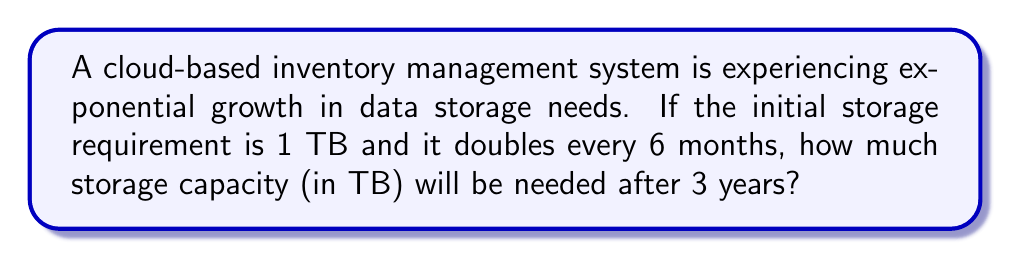Solve this math problem. Let's approach this step-by-step:

1) First, we need to identify the key components of the exponential sequence:
   - Initial value: $a = 1$ TB
   - Growth factor: $r = 2$ (doubles every period)
   - Time periods: $n = 6$ (3 years = 36 months, which is 6 six-month periods)

2) The general formula for an exponential sequence is:
   $$ a_n = a \cdot r^n $$
   Where $a_n$ is the value after $n$ periods, $a$ is the initial value, $r$ is the growth factor, and $n$ is the number of periods.

3) Plugging in our values:
   $$ a_6 = 1 \cdot 2^6 $$

4) Calculate $2^6$:
   $$ 2^6 = 2 \times 2 \times 2 \times 2 \times 2 \times 2 = 64 $$

5) Therefore, the final storage capacity needed after 3 years will be:
   $$ a_6 = 1 \cdot 64 = 64 \text{ TB} $$

This exponential growth demonstrates the rapid scalability required for cloud resources in a fast-growing inventory management system.
Answer: 64 TB 